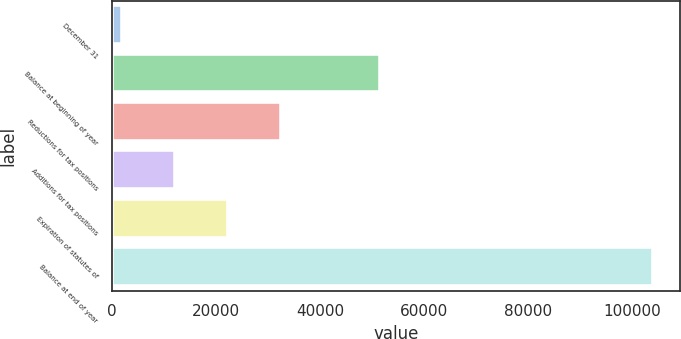Convert chart. <chart><loc_0><loc_0><loc_500><loc_500><bar_chart><fcel>December 31<fcel>Balance at beginning of year<fcel>Reductions for tax positions<fcel>Additions for tax positions<fcel>Expiration of statutes of<fcel>Balance at end of year<nl><fcel>2013<fcel>51520<fcel>32598<fcel>12208<fcel>22403<fcel>103963<nl></chart> 